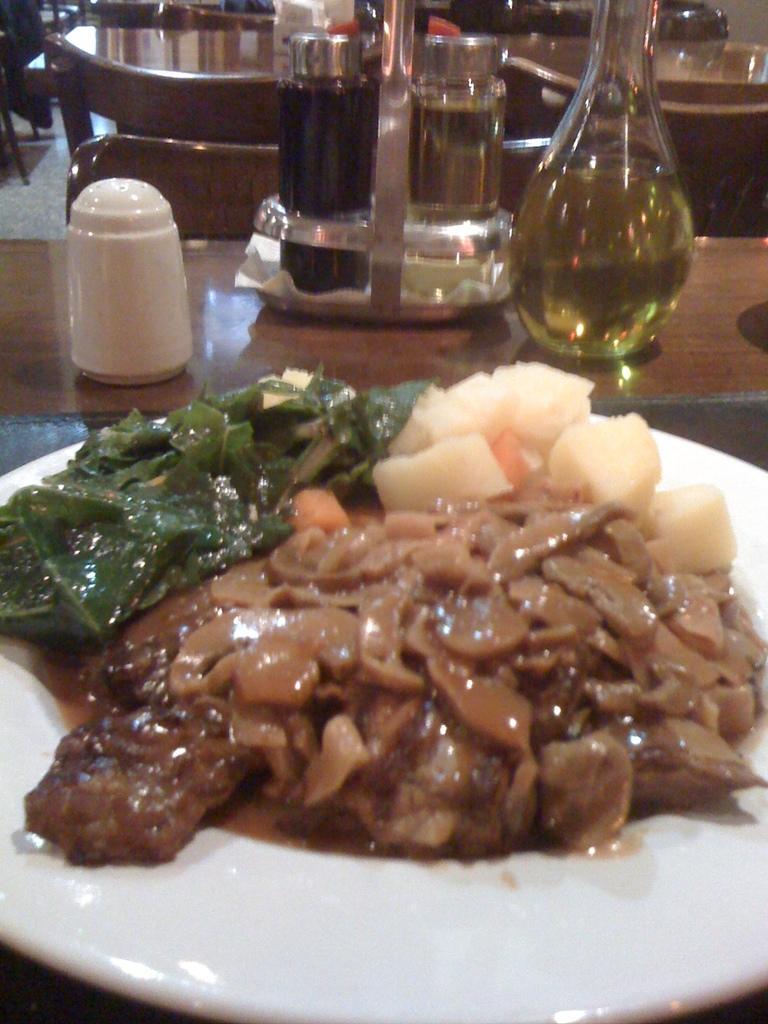How would you summarize this image in a sentence or two? In this image, there is a table contains some bottles. There is a plate at the bottom of the image contains some food. 